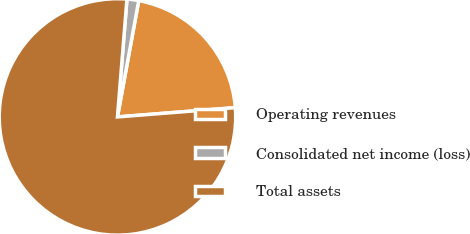<chart> <loc_0><loc_0><loc_500><loc_500><pie_chart><fcel>Operating revenues<fcel>Consolidated net income (loss)<fcel>Total assets<nl><fcel>20.87%<fcel>1.6%<fcel>77.53%<nl></chart> 